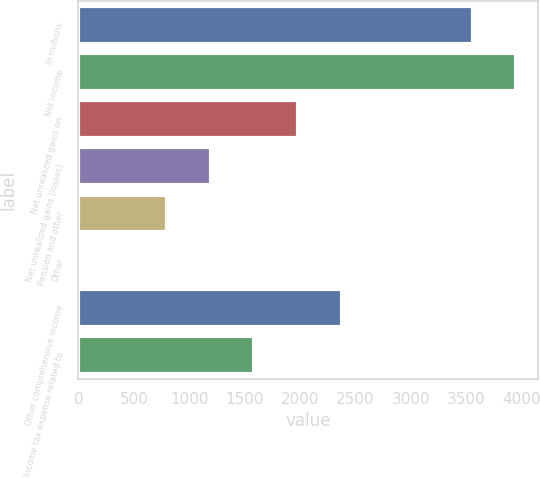<chart> <loc_0><loc_0><loc_500><loc_500><bar_chart><fcel>In millions<fcel>Net income<fcel>Net unrealized gains on<fcel>Net unrealized gains (losses)<fcel>Pension and other<fcel>Other<fcel>Other comprehensive income<fcel>Income tax expense related to<nl><fcel>3557.8<fcel>3952<fcel>1981<fcel>1192.6<fcel>798.4<fcel>10<fcel>2375.2<fcel>1586.8<nl></chart> 